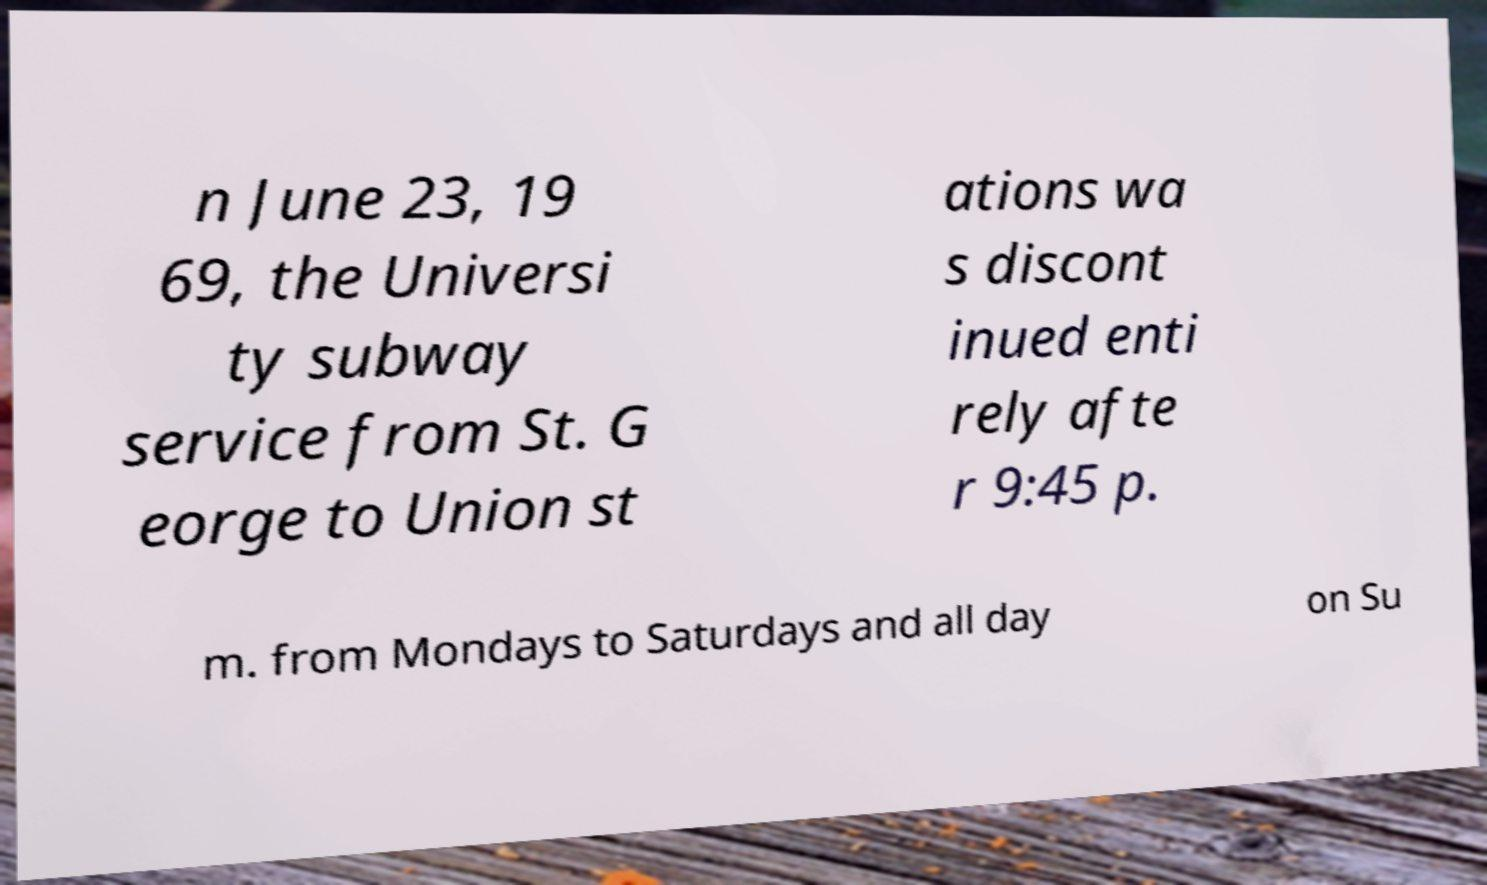There's text embedded in this image that I need extracted. Can you transcribe it verbatim? n June 23, 19 69, the Universi ty subway service from St. G eorge to Union st ations wa s discont inued enti rely afte r 9:45 p. m. from Mondays to Saturdays and all day on Su 